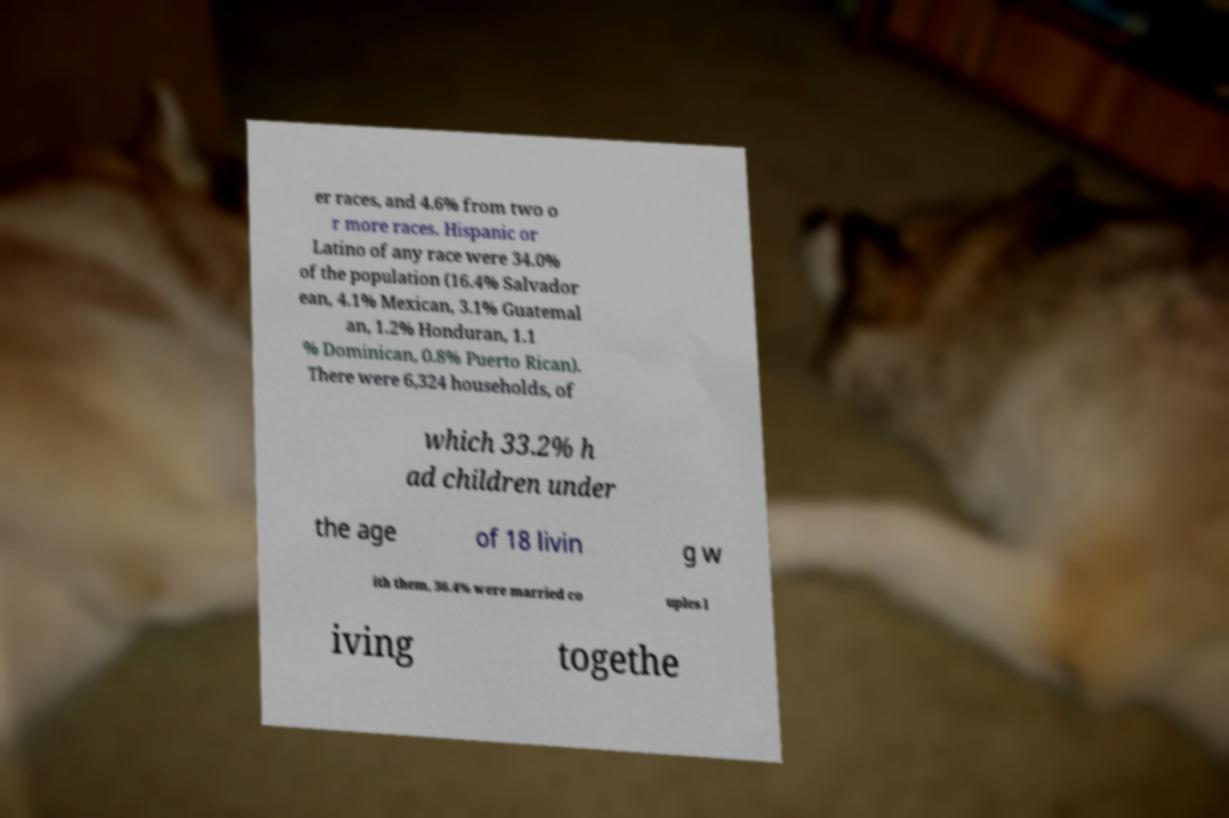Please identify and transcribe the text found in this image. er races, and 4.6% from two o r more races. Hispanic or Latino of any race were 34.0% of the population (16.4% Salvador ean, 4.1% Mexican, 3.1% Guatemal an, 1.2% Honduran, 1.1 % Dominican, 0.8% Puerto Rican). There were 6,324 households, of which 33.2% h ad children under the age of 18 livin g w ith them, 36.4% were married co uples l iving togethe 